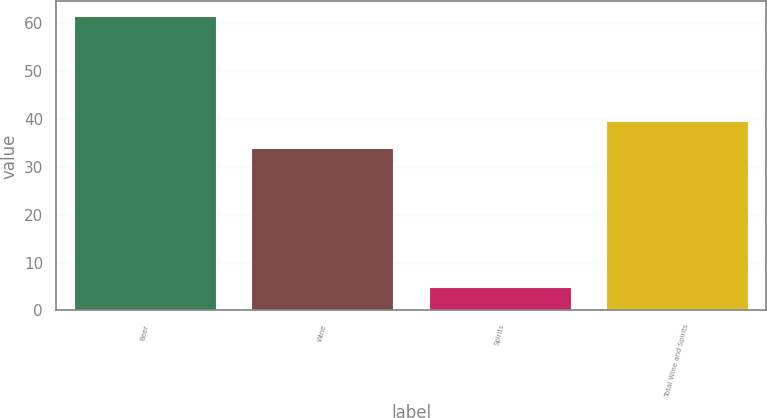<chart> <loc_0><loc_0><loc_500><loc_500><bar_chart><fcel>Beer<fcel>Wine<fcel>Spirits<fcel>Total Wine and Spirits<nl><fcel>61.4<fcel>33.8<fcel>4.8<fcel>39.46<nl></chart> 